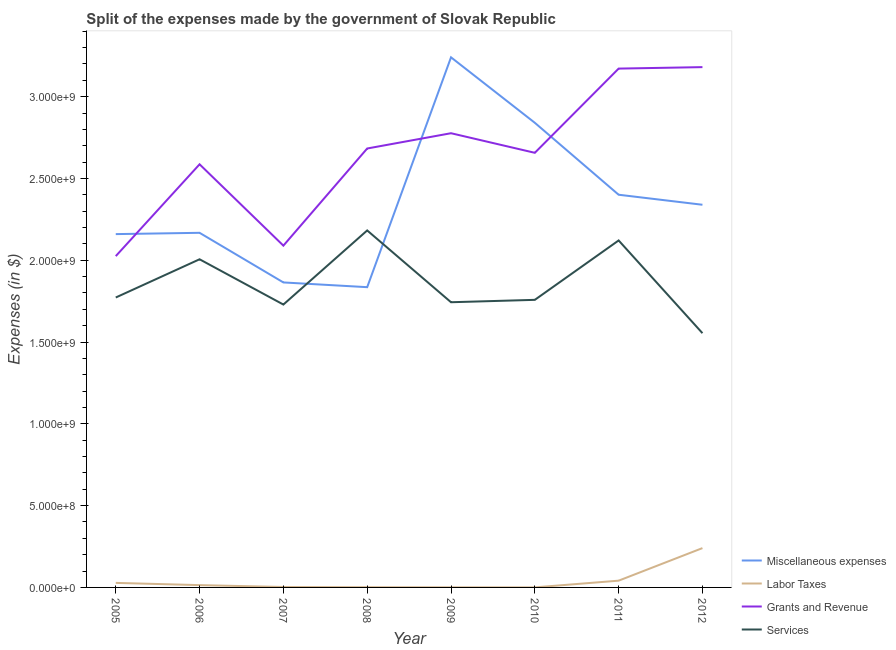What is the amount spent on grants and revenue in 2009?
Provide a short and direct response. 2.78e+09. Across all years, what is the maximum amount spent on grants and revenue?
Provide a succinct answer. 3.18e+09. Across all years, what is the minimum amount spent on miscellaneous expenses?
Provide a short and direct response. 1.84e+09. In which year was the amount spent on services maximum?
Your answer should be compact. 2008. What is the total amount spent on services in the graph?
Your answer should be compact. 1.49e+1. What is the difference between the amount spent on labor taxes in 2005 and that in 2012?
Ensure brevity in your answer.  -2.13e+08. What is the difference between the amount spent on grants and revenue in 2007 and the amount spent on services in 2006?
Offer a terse response. 8.34e+07. What is the average amount spent on miscellaneous expenses per year?
Offer a very short reply. 2.36e+09. In the year 2011, what is the difference between the amount spent on grants and revenue and amount spent on miscellaneous expenses?
Ensure brevity in your answer.  7.71e+08. In how many years, is the amount spent on miscellaneous expenses greater than 1100000000 $?
Provide a succinct answer. 8. What is the ratio of the amount spent on labor taxes in 2008 to that in 2009?
Offer a terse response. 1.92. Is the amount spent on services in 2005 less than that in 2006?
Provide a succinct answer. Yes. Is the difference between the amount spent on labor taxes in 2006 and 2010 greater than the difference between the amount spent on services in 2006 and 2010?
Provide a short and direct response. No. What is the difference between the highest and the second highest amount spent on labor taxes?
Offer a terse response. 1.99e+08. What is the difference between the highest and the lowest amount spent on services?
Provide a short and direct response. 6.28e+08. Is the sum of the amount spent on services in 2009 and 2012 greater than the maximum amount spent on grants and revenue across all years?
Provide a succinct answer. Yes. Is it the case that in every year, the sum of the amount spent on grants and revenue and amount spent on miscellaneous expenses is greater than the sum of amount spent on labor taxes and amount spent on services?
Offer a terse response. Yes. Is it the case that in every year, the sum of the amount spent on miscellaneous expenses and amount spent on labor taxes is greater than the amount spent on grants and revenue?
Your answer should be very brief. No. How many lines are there?
Keep it short and to the point. 4. Does the graph contain any zero values?
Offer a terse response. No. Where does the legend appear in the graph?
Your response must be concise. Bottom right. What is the title of the graph?
Make the answer very short. Split of the expenses made by the government of Slovak Republic. What is the label or title of the Y-axis?
Provide a succinct answer. Expenses (in $). What is the Expenses (in $) of Miscellaneous expenses in 2005?
Provide a succinct answer. 2.16e+09. What is the Expenses (in $) in Labor Taxes in 2005?
Your answer should be very brief. 2.77e+07. What is the Expenses (in $) in Grants and Revenue in 2005?
Offer a very short reply. 2.03e+09. What is the Expenses (in $) in Services in 2005?
Your response must be concise. 1.77e+09. What is the Expenses (in $) in Miscellaneous expenses in 2006?
Ensure brevity in your answer.  2.17e+09. What is the Expenses (in $) in Labor Taxes in 2006?
Give a very brief answer. 1.41e+07. What is the Expenses (in $) of Grants and Revenue in 2006?
Provide a succinct answer. 2.59e+09. What is the Expenses (in $) in Services in 2006?
Provide a succinct answer. 2.01e+09. What is the Expenses (in $) in Miscellaneous expenses in 2007?
Your response must be concise. 1.86e+09. What is the Expenses (in $) of Labor Taxes in 2007?
Give a very brief answer. 2.58e+06. What is the Expenses (in $) in Grants and Revenue in 2007?
Provide a short and direct response. 2.09e+09. What is the Expenses (in $) of Services in 2007?
Your answer should be compact. 1.73e+09. What is the Expenses (in $) of Miscellaneous expenses in 2008?
Offer a terse response. 1.84e+09. What is the Expenses (in $) in Labor Taxes in 2008?
Offer a very short reply. 1.39e+06. What is the Expenses (in $) of Grants and Revenue in 2008?
Keep it short and to the point. 2.68e+09. What is the Expenses (in $) of Services in 2008?
Your answer should be very brief. 2.18e+09. What is the Expenses (in $) in Miscellaneous expenses in 2009?
Offer a very short reply. 3.24e+09. What is the Expenses (in $) in Labor Taxes in 2009?
Your answer should be compact. 7.25e+05. What is the Expenses (in $) in Grants and Revenue in 2009?
Keep it short and to the point. 2.78e+09. What is the Expenses (in $) of Services in 2009?
Your answer should be very brief. 1.74e+09. What is the Expenses (in $) of Miscellaneous expenses in 2010?
Keep it short and to the point. 2.84e+09. What is the Expenses (in $) in Labor Taxes in 2010?
Your answer should be compact. 3.61e+05. What is the Expenses (in $) in Grants and Revenue in 2010?
Offer a terse response. 2.66e+09. What is the Expenses (in $) in Services in 2010?
Your answer should be very brief. 1.76e+09. What is the Expenses (in $) in Miscellaneous expenses in 2011?
Provide a short and direct response. 2.40e+09. What is the Expenses (in $) of Labor Taxes in 2011?
Make the answer very short. 4.13e+07. What is the Expenses (in $) of Grants and Revenue in 2011?
Offer a very short reply. 3.17e+09. What is the Expenses (in $) in Services in 2011?
Your answer should be compact. 2.12e+09. What is the Expenses (in $) of Miscellaneous expenses in 2012?
Ensure brevity in your answer.  2.34e+09. What is the Expenses (in $) of Labor Taxes in 2012?
Offer a terse response. 2.40e+08. What is the Expenses (in $) of Grants and Revenue in 2012?
Your answer should be compact. 3.18e+09. What is the Expenses (in $) of Services in 2012?
Make the answer very short. 1.55e+09. Across all years, what is the maximum Expenses (in $) of Miscellaneous expenses?
Give a very brief answer. 3.24e+09. Across all years, what is the maximum Expenses (in $) of Labor Taxes?
Offer a very short reply. 2.40e+08. Across all years, what is the maximum Expenses (in $) of Grants and Revenue?
Provide a short and direct response. 3.18e+09. Across all years, what is the maximum Expenses (in $) in Services?
Your response must be concise. 2.18e+09. Across all years, what is the minimum Expenses (in $) in Miscellaneous expenses?
Offer a terse response. 1.84e+09. Across all years, what is the minimum Expenses (in $) of Labor Taxes?
Provide a succinct answer. 3.61e+05. Across all years, what is the minimum Expenses (in $) in Grants and Revenue?
Make the answer very short. 2.03e+09. Across all years, what is the minimum Expenses (in $) in Services?
Provide a short and direct response. 1.55e+09. What is the total Expenses (in $) of Miscellaneous expenses in the graph?
Provide a succinct answer. 1.88e+1. What is the total Expenses (in $) of Labor Taxes in the graph?
Make the answer very short. 3.29e+08. What is the total Expenses (in $) of Grants and Revenue in the graph?
Offer a very short reply. 2.12e+1. What is the total Expenses (in $) in Services in the graph?
Keep it short and to the point. 1.49e+1. What is the difference between the Expenses (in $) of Miscellaneous expenses in 2005 and that in 2006?
Provide a succinct answer. -7.93e+06. What is the difference between the Expenses (in $) in Labor Taxes in 2005 and that in 2006?
Provide a short and direct response. 1.36e+07. What is the difference between the Expenses (in $) of Grants and Revenue in 2005 and that in 2006?
Offer a very short reply. -5.61e+08. What is the difference between the Expenses (in $) in Services in 2005 and that in 2006?
Make the answer very short. -2.34e+08. What is the difference between the Expenses (in $) in Miscellaneous expenses in 2005 and that in 2007?
Provide a succinct answer. 2.95e+08. What is the difference between the Expenses (in $) in Labor Taxes in 2005 and that in 2007?
Ensure brevity in your answer.  2.51e+07. What is the difference between the Expenses (in $) of Grants and Revenue in 2005 and that in 2007?
Make the answer very short. -6.41e+07. What is the difference between the Expenses (in $) of Services in 2005 and that in 2007?
Your response must be concise. 4.31e+07. What is the difference between the Expenses (in $) of Miscellaneous expenses in 2005 and that in 2008?
Provide a short and direct response. 3.24e+08. What is the difference between the Expenses (in $) in Labor Taxes in 2005 and that in 2008?
Ensure brevity in your answer.  2.63e+07. What is the difference between the Expenses (in $) of Grants and Revenue in 2005 and that in 2008?
Keep it short and to the point. -6.58e+08. What is the difference between the Expenses (in $) of Services in 2005 and that in 2008?
Provide a short and direct response. -4.10e+08. What is the difference between the Expenses (in $) of Miscellaneous expenses in 2005 and that in 2009?
Offer a terse response. -1.08e+09. What is the difference between the Expenses (in $) of Labor Taxes in 2005 and that in 2009?
Offer a terse response. 2.70e+07. What is the difference between the Expenses (in $) in Grants and Revenue in 2005 and that in 2009?
Make the answer very short. -7.51e+08. What is the difference between the Expenses (in $) in Services in 2005 and that in 2009?
Your answer should be very brief. 2.89e+07. What is the difference between the Expenses (in $) in Miscellaneous expenses in 2005 and that in 2010?
Make the answer very short. -6.81e+08. What is the difference between the Expenses (in $) in Labor Taxes in 2005 and that in 2010?
Provide a succinct answer. 2.73e+07. What is the difference between the Expenses (in $) of Grants and Revenue in 2005 and that in 2010?
Give a very brief answer. -6.32e+08. What is the difference between the Expenses (in $) of Services in 2005 and that in 2010?
Give a very brief answer. 1.44e+07. What is the difference between the Expenses (in $) of Miscellaneous expenses in 2005 and that in 2011?
Your response must be concise. -2.41e+08. What is the difference between the Expenses (in $) in Labor Taxes in 2005 and that in 2011?
Your response must be concise. -1.36e+07. What is the difference between the Expenses (in $) in Grants and Revenue in 2005 and that in 2011?
Offer a terse response. -1.15e+09. What is the difference between the Expenses (in $) in Services in 2005 and that in 2011?
Offer a terse response. -3.49e+08. What is the difference between the Expenses (in $) in Miscellaneous expenses in 2005 and that in 2012?
Offer a terse response. -1.79e+08. What is the difference between the Expenses (in $) of Labor Taxes in 2005 and that in 2012?
Your answer should be compact. -2.13e+08. What is the difference between the Expenses (in $) of Grants and Revenue in 2005 and that in 2012?
Your answer should be compact. -1.16e+09. What is the difference between the Expenses (in $) of Services in 2005 and that in 2012?
Give a very brief answer. 2.18e+08. What is the difference between the Expenses (in $) of Miscellaneous expenses in 2006 and that in 2007?
Your answer should be very brief. 3.03e+08. What is the difference between the Expenses (in $) in Labor Taxes in 2006 and that in 2007?
Offer a very short reply. 1.15e+07. What is the difference between the Expenses (in $) in Grants and Revenue in 2006 and that in 2007?
Offer a terse response. 4.97e+08. What is the difference between the Expenses (in $) in Services in 2006 and that in 2007?
Make the answer very short. 2.77e+08. What is the difference between the Expenses (in $) of Miscellaneous expenses in 2006 and that in 2008?
Keep it short and to the point. 3.32e+08. What is the difference between the Expenses (in $) in Labor Taxes in 2006 and that in 2008?
Give a very brief answer. 1.27e+07. What is the difference between the Expenses (in $) in Grants and Revenue in 2006 and that in 2008?
Keep it short and to the point. -9.66e+07. What is the difference between the Expenses (in $) in Services in 2006 and that in 2008?
Provide a short and direct response. -1.76e+08. What is the difference between the Expenses (in $) in Miscellaneous expenses in 2006 and that in 2009?
Your answer should be very brief. -1.07e+09. What is the difference between the Expenses (in $) in Labor Taxes in 2006 and that in 2009?
Keep it short and to the point. 1.34e+07. What is the difference between the Expenses (in $) of Grants and Revenue in 2006 and that in 2009?
Ensure brevity in your answer.  -1.90e+08. What is the difference between the Expenses (in $) in Services in 2006 and that in 2009?
Offer a terse response. 2.63e+08. What is the difference between the Expenses (in $) in Miscellaneous expenses in 2006 and that in 2010?
Your response must be concise. -6.73e+08. What is the difference between the Expenses (in $) of Labor Taxes in 2006 and that in 2010?
Make the answer very short. 1.37e+07. What is the difference between the Expenses (in $) in Grants and Revenue in 2006 and that in 2010?
Give a very brief answer. -7.03e+07. What is the difference between the Expenses (in $) in Services in 2006 and that in 2010?
Your response must be concise. 2.48e+08. What is the difference between the Expenses (in $) in Miscellaneous expenses in 2006 and that in 2011?
Your answer should be compact. -2.33e+08. What is the difference between the Expenses (in $) in Labor Taxes in 2006 and that in 2011?
Ensure brevity in your answer.  -2.72e+07. What is the difference between the Expenses (in $) in Grants and Revenue in 2006 and that in 2011?
Give a very brief answer. -5.85e+08. What is the difference between the Expenses (in $) in Services in 2006 and that in 2011?
Your answer should be compact. -1.15e+08. What is the difference between the Expenses (in $) of Miscellaneous expenses in 2006 and that in 2012?
Ensure brevity in your answer.  -1.72e+08. What is the difference between the Expenses (in $) in Labor Taxes in 2006 and that in 2012?
Your answer should be very brief. -2.26e+08. What is the difference between the Expenses (in $) of Grants and Revenue in 2006 and that in 2012?
Keep it short and to the point. -5.94e+08. What is the difference between the Expenses (in $) of Services in 2006 and that in 2012?
Give a very brief answer. 4.52e+08. What is the difference between the Expenses (in $) in Miscellaneous expenses in 2007 and that in 2008?
Ensure brevity in your answer.  2.90e+07. What is the difference between the Expenses (in $) in Labor Taxes in 2007 and that in 2008?
Make the answer very short. 1.19e+06. What is the difference between the Expenses (in $) in Grants and Revenue in 2007 and that in 2008?
Give a very brief answer. -5.94e+08. What is the difference between the Expenses (in $) of Services in 2007 and that in 2008?
Make the answer very short. -4.53e+08. What is the difference between the Expenses (in $) in Miscellaneous expenses in 2007 and that in 2009?
Your response must be concise. -1.38e+09. What is the difference between the Expenses (in $) of Labor Taxes in 2007 and that in 2009?
Your response must be concise. 1.86e+06. What is the difference between the Expenses (in $) in Grants and Revenue in 2007 and that in 2009?
Ensure brevity in your answer.  -6.87e+08. What is the difference between the Expenses (in $) of Services in 2007 and that in 2009?
Make the answer very short. -1.42e+07. What is the difference between the Expenses (in $) in Miscellaneous expenses in 2007 and that in 2010?
Give a very brief answer. -9.76e+08. What is the difference between the Expenses (in $) of Labor Taxes in 2007 and that in 2010?
Give a very brief answer. 2.22e+06. What is the difference between the Expenses (in $) of Grants and Revenue in 2007 and that in 2010?
Keep it short and to the point. -5.68e+08. What is the difference between the Expenses (in $) in Services in 2007 and that in 2010?
Make the answer very short. -2.88e+07. What is the difference between the Expenses (in $) of Miscellaneous expenses in 2007 and that in 2011?
Offer a very short reply. -5.36e+08. What is the difference between the Expenses (in $) of Labor Taxes in 2007 and that in 2011?
Keep it short and to the point. -3.87e+07. What is the difference between the Expenses (in $) in Grants and Revenue in 2007 and that in 2011?
Offer a very short reply. -1.08e+09. What is the difference between the Expenses (in $) in Services in 2007 and that in 2011?
Provide a short and direct response. -3.92e+08. What is the difference between the Expenses (in $) of Miscellaneous expenses in 2007 and that in 2012?
Ensure brevity in your answer.  -4.75e+08. What is the difference between the Expenses (in $) in Labor Taxes in 2007 and that in 2012?
Your answer should be compact. -2.38e+08. What is the difference between the Expenses (in $) of Grants and Revenue in 2007 and that in 2012?
Provide a succinct answer. -1.09e+09. What is the difference between the Expenses (in $) in Services in 2007 and that in 2012?
Keep it short and to the point. 1.75e+08. What is the difference between the Expenses (in $) in Miscellaneous expenses in 2008 and that in 2009?
Your answer should be very brief. -1.41e+09. What is the difference between the Expenses (in $) of Labor Taxes in 2008 and that in 2009?
Give a very brief answer. 6.67e+05. What is the difference between the Expenses (in $) in Grants and Revenue in 2008 and that in 2009?
Offer a terse response. -9.34e+07. What is the difference between the Expenses (in $) in Services in 2008 and that in 2009?
Your response must be concise. 4.39e+08. What is the difference between the Expenses (in $) in Miscellaneous expenses in 2008 and that in 2010?
Provide a short and direct response. -1.00e+09. What is the difference between the Expenses (in $) in Labor Taxes in 2008 and that in 2010?
Provide a succinct answer. 1.03e+06. What is the difference between the Expenses (in $) in Grants and Revenue in 2008 and that in 2010?
Keep it short and to the point. 2.63e+07. What is the difference between the Expenses (in $) of Services in 2008 and that in 2010?
Your answer should be very brief. 4.24e+08. What is the difference between the Expenses (in $) of Miscellaneous expenses in 2008 and that in 2011?
Your answer should be very brief. -5.65e+08. What is the difference between the Expenses (in $) in Labor Taxes in 2008 and that in 2011?
Ensure brevity in your answer.  -3.99e+07. What is the difference between the Expenses (in $) of Grants and Revenue in 2008 and that in 2011?
Keep it short and to the point. -4.88e+08. What is the difference between the Expenses (in $) in Services in 2008 and that in 2011?
Keep it short and to the point. 6.11e+07. What is the difference between the Expenses (in $) in Miscellaneous expenses in 2008 and that in 2012?
Offer a very short reply. -5.04e+08. What is the difference between the Expenses (in $) of Labor Taxes in 2008 and that in 2012?
Your response must be concise. -2.39e+08. What is the difference between the Expenses (in $) of Grants and Revenue in 2008 and that in 2012?
Provide a short and direct response. -4.97e+08. What is the difference between the Expenses (in $) in Services in 2008 and that in 2012?
Your answer should be compact. 6.28e+08. What is the difference between the Expenses (in $) of Miscellaneous expenses in 2009 and that in 2010?
Offer a very short reply. 4.00e+08. What is the difference between the Expenses (in $) in Labor Taxes in 2009 and that in 2010?
Offer a very short reply. 3.64e+05. What is the difference between the Expenses (in $) of Grants and Revenue in 2009 and that in 2010?
Make the answer very short. 1.20e+08. What is the difference between the Expenses (in $) of Services in 2009 and that in 2010?
Give a very brief answer. -1.45e+07. What is the difference between the Expenses (in $) of Miscellaneous expenses in 2009 and that in 2011?
Your response must be concise. 8.40e+08. What is the difference between the Expenses (in $) in Labor Taxes in 2009 and that in 2011?
Offer a terse response. -4.06e+07. What is the difference between the Expenses (in $) in Grants and Revenue in 2009 and that in 2011?
Give a very brief answer. -3.95e+08. What is the difference between the Expenses (in $) of Services in 2009 and that in 2011?
Ensure brevity in your answer.  -3.78e+08. What is the difference between the Expenses (in $) of Miscellaneous expenses in 2009 and that in 2012?
Ensure brevity in your answer.  9.01e+08. What is the difference between the Expenses (in $) in Labor Taxes in 2009 and that in 2012?
Your response must be concise. -2.40e+08. What is the difference between the Expenses (in $) of Grants and Revenue in 2009 and that in 2012?
Your answer should be compact. -4.04e+08. What is the difference between the Expenses (in $) of Services in 2009 and that in 2012?
Your answer should be very brief. 1.89e+08. What is the difference between the Expenses (in $) of Miscellaneous expenses in 2010 and that in 2011?
Your response must be concise. 4.40e+08. What is the difference between the Expenses (in $) in Labor Taxes in 2010 and that in 2011?
Provide a succinct answer. -4.10e+07. What is the difference between the Expenses (in $) of Grants and Revenue in 2010 and that in 2011?
Offer a terse response. -5.15e+08. What is the difference between the Expenses (in $) of Services in 2010 and that in 2011?
Offer a terse response. -3.63e+08. What is the difference between the Expenses (in $) of Miscellaneous expenses in 2010 and that in 2012?
Make the answer very short. 5.01e+08. What is the difference between the Expenses (in $) in Labor Taxes in 2010 and that in 2012?
Your answer should be very brief. -2.40e+08. What is the difference between the Expenses (in $) of Grants and Revenue in 2010 and that in 2012?
Keep it short and to the point. -5.24e+08. What is the difference between the Expenses (in $) of Services in 2010 and that in 2012?
Your answer should be compact. 2.04e+08. What is the difference between the Expenses (in $) of Miscellaneous expenses in 2011 and that in 2012?
Offer a very short reply. 6.13e+07. What is the difference between the Expenses (in $) of Labor Taxes in 2011 and that in 2012?
Provide a short and direct response. -1.99e+08. What is the difference between the Expenses (in $) of Grants and Revenue in 2011 and that in 2012?
Your answer should be compact. -8.98e+06. What is the difference between the Expenses (in $) of Services in 2011 and that in 2012?
Give a very brief answer. 5.67e+08. What is the difference between the Expenses (in $) of Miscellaneous expenses in 2005 and the Expenses (in $) of Labor Taxes in 2006?
Provide a succinct answer. 2.15e+09. What is the difference between the Expenses (in $) in Miscellaneous expenses in 2005 and the Expenses (in $) in Grants and Revenue in 2006?
Your answer should be compact. -4.27e+08. What is the difference between the Expenses (in $) in Miscellaneous expenses in 2005 and the Expenses (in $) in Services in 2006?
Provide a short and direct response. 1.54e+08. What is the difference between the Expenses (in $) of Labor Taxes in 2005 and the Expenses (in $) of Grants and Revenue in 2006?
Offer a terse response. -2.56e+09. What is the difference between the Expenses (in $) of Labor Taxes in 2005 and the Expenses (in $) of Services in 2006?
Offer a very short reply. -1.98e+09. What is the difference between the Expenses (in $) in Grants and Revenue in 2005 and the Expenses (in $) in Services in 2006?
Ensure brevity in your answer.  1.93e+07. What is the difference between the Expenses (in $) of Miscellaneous expenses in 2005 and the Expenses (in $) of Labor Taxes in 2007?
Provide a short and direct response. 2.16e+09. What is the difference between the Expenses (in $) of Miscellaneous expenses in 2005 and the Expenses (in $) of Grants and Revenue in 2007?
Your answer should be compact. 7.04e+07. What is the difference between the Expenses (in $) in Miscellaneous expenses in 2005 and the Expenses (in $) in Services in 2007?
Offer a very short reply. 4.31e+08. What is the difference between the Expenses (in $) in Labor Taxes in 2005 and the Expenses (in $) in Grants and Revenue in 2007?
Your response must be concise. -2.06e+09. What is the difference between the Expenses (in $) of Labor Taxes in 2005 and the Expenses (in $) of Services in 2007?
Keep it short and to the point. -1.70e+09. What is the difference between the Expenses (in $) of Grants and Revenue in 2005 and the Expenses (in $) of Services in 2007?
Make the answer very short. 2.96e+08. What is the difference between the Expenses (in $) in Miscellaneous expenses in 2005 and the Expenses (in $) in Labor Taxes in 2008?
Keep it short and to the point. 2.16e+09. What is the difference between the Expenses (in $) in Miscellaneous expenses in 2005 and the Expenses (in $) in Grants and Revenue in 2008?
Offer a terse response. -5.23e+08. What is the difference between the Expenses (in $) in Miscellaneous expenses in 2005 and the Expenses (in $) in Services in 2008?
Your answer should be compact. -2.25e+07. What is the difference between the Expenses (in $) in Labor Taxes in 2005 and the Expenses (in $) in Grants and Revenue in 2008?
Offer a terse response. -2.66e+09. What is the difference between the Expenses (in $) of Labor Taxes in 2005 and the Expenses (in $) of Services in 2008?
Offer a terse response. -2.15e+09. What is the difference between the Expenses (in $) in Grants and Revenue in 2005 and the Expenses (in $) in Services in 2008?
Your answer should be compact. -1.57e+08. What is the difference between the Expenses (in $) in Miscellaneous expenses in 2005 and the Expenses (in $) in Labor Taxes in 2009?
Make the answer very short. 2.16e+09. What is the difference between the Expenses (in $) in Miscellaneous expenses in 2005 and the Expenses (in $) in Grants and Revenue in 2009?
Your answer should be compact. -6.17e+08. What is the difference between the Expenses (in $) in Miscellaneous expenses in 2005 and the Expenses (in $) in Services in 2009?
Ensure brevity in your answer.  4.16e+08. What is the difference between the Expenses (in $) of Labor Taxes in 2005 and the Expenses (in $) of Grants and Revenue in 2009?
Ensure brevity in your answer.  -2.75e+09. What is the difference between the Expenses (in $) of Labor Taxes in 2005 and the Expenses (in $) of Services in 2009?
Ensure brevity in your answer.  -1.72e+09. What is the difference between the Expenses (in $) in Grants and Revenue in 2005 and the Expenses (in $) in Services in 2009?
Your answer should be very brief. 2.82e+08. What is the difference between the Expenses (in $) in Miscellaneous expenses in 2005 and the Expenses (in $) in Labor Taxes in 2010?
Your answer should be compact. 2.16e+09. What is the difference between the Expenses (in $) in Miscellaneous expenses in 2005 and the Expenses (in $) in Grants and Revenue in 2010?
Offer a terse response. -4.97e+08. What is the difference between the Expenses (in $) of Miscellaneous expenses in 2005 and the Expenses (in $) of Services in 2010?
Offer a very short reply. 4.02e+08. What is the difference between the Expenses (in $) of Labor Taxes in 2005 and the Expenses (in $) of Grants and Revenue in 2010?
Keep it short and to the point. -2.63e+09. What is the difference between the Expenses (in $) in Labor Taxes in 2005 and the Expenses (in $) in Services in 2010?
Provide a short and direct response. -1.73e+09. What is the difference between the Expenses (in $) of Grants and Revenue in 2005 and the Expenses (in $) of Services in 2010?
Offer a very short reply. 2.67e+08. What is the difference between the Expenses (in $) in Miscellaneous expenses in 2005 and the Expenses (in $) in Labor Taxes in 2011?
Give a very brief answer. 2.12e+09. What is the difference between the Expenses (in $) in Miscellaneous expenses in 2005 and the Expenses (in $) in Grants and Revenue in 2011?
Your answer should be very brief. -1.01e+09. What is the difference between the Expenses (in $) in Miscellaneous expenses in 2005 and the Expenses (in $) in Services in 2011?
Your response must be concise. 3.87e+07. What is the difference between the Expenses (in $) of Labor Taxes in 2005 and the Expenses (in $) of Grants and Revenue in 2011?
Keep it short and to the point. -3.14e+09. What is the difference between the Expenses (in $) of Labor Taxes in 2005 and the Expenses (in $) of Services in 2011?
Provide a succinct answer. -2.09e+09. What is the difference between the Expenses (in $) of Grants and Revenue in 2005 and the Expenses (in $) of Services in 2011?
Offer a very short reply. -9.59e+07. What is the difference between the Expenses (in $) of Miscellaneous expenses in 2005 and the Expenses (in $) of Labor Taxes in 2012?
Provide a short and direct response. 1.92e+09. What is the difference between the Expenses (in $) in Miscellaneous expenses in 2005 and the Expenses (in $) in Grants and Revenue in 2012?
Provide a succinct answer. -1.02e+09. What is the difference between the Expenses (in $) in Miscellaneous expenses in 2005 and the Expenses (in $) in Services in 2012?
Your answer should be very brief. 6.06e+08. What is the difference between the Expenses (in $) in Labor Taxes in 2005 and the Expenses (in $) in Grants and Revenue in 2012?
Your answer should be very brief. -3.15e+09. What is the difference between the Expenses (in $) in Labor Taxes in 2005 and the Expenses (in $) in Services in 2012?
Your answer should be very brief. -1.53e+09. What is the difference between the Expenses (in $) of Grants and Revenue in 2005 and the Expenses (in $) of Services in 2012?
Your answer should be very brief. 4.71e+08. What is the difference between the Expenses (in $) in Miscellaneous expenses in 2006 and the Expenses (in $) in Labor Taxes in 2007?
Keep it short and to the point. 2.17e+09. What is the difference between the Expenses (in $) in Miscellaneous expenses in 2006 and the Expenses (in $) in Grants and Revenue in 2007?
Give a very brief answer. 7.84e+07. What is the difference between the Expenses (in $) in Miscellaneous expenses in 2006 and the Expenses (in $) in Services in 2007?
Your answer should be very brief. 4.39e+08. What is the difference between the Expenses (in $) in Labor Taxes in 2006 and the Expenses (in $) in Grants and Revenue in 2007?
Your answer should be very brief. -2.08e+09. What is the difference between the Expenses (in $) of Labor Taxes in 2006 and the Expenses (in $) of Services in 2007?
Your answer should be compact. -1.72e+09. What is the difference between the Expenses (in $) in Grants and Revenue in 2006 and the Expenses (in $) in Services in 2007?
Give a very brief answer. 8.57e+08. What is the difference between the Expenses (in $) of Miscellaneous expenses in 2006 and the Expenses (in $) of Labor Taxes in 2008?
Ensure brevity in your answer.  2.17e+09. What is the difference between the Expenses (in $) of Miscellaneous expenses in 2006 and the Expenses (in $) of Grants and Revenue in 2008?
Ensure brevity in your answer.  -5.15e+08. What is the difference between the Expenses (in $) of Miscellaneous expenses in 2006 and the Expenses (in $) of Services in 2008?
Your response must be concise. -1.45e+07. What is the difference between the Expenses (in $) in Labor Taxes in 2006 and the Expenses (in $) in Grants and Revenue in 2008?
Provide a short and direct response. -2.67e+09. What is the difference between the Expenses (in $) of Labor Taxes in 2006 and the Expenses (in $) of Services in 2008?
Offer a terse response. -2.17e+09. What is the difference between the Expenses (in $) of Grants and Revenue in 2006 and the Expenses (in $) of Services in 2008?
Provide a succinct answer. 4.04e+08. What is the difference between the Expenses (in $) in Miscellaneous expenses in 2006 and the Expenses (in $) in Labor Taxes in 2009?
Your answer should be very brief. 2.17e+09. What is the difference between the Expenses (in $) of Miscellaneous expenses in 2006 and the Expenses (in $) of Grants and Revenue in 2009?
Provide a succinct answer. -6.09e+08. What is the difference between the Expenses (in $) in Miscellaneous expenses in 2006 and the Expenses (in $) in Services in 2009?
Offer a terse response. 4.24e+08. What is the difference between the Expenses (in $) in Labor Taxes in 2006 and the Expenses (in $) in Grants and Revenue in 2009?
Ensure brevity in your answer.  -2.76e+09. What is the difference between the Expenses (in $) of Labor Taxes in 2006 and the Expenses (in $) of Services in 2009?
Your answer should be very brief. -1.73e+09. What is the difference between the Expenses (in $) in Grants and Revenue in 2006 and the Expenses (in $) in Services in 2009?
Your answer should be very brief. 8.43e+08. What is the difference between the Expenses (in $) in Miscellaneous expenses in 2006 and the Expenses (in $) in Labor Taxes in 2010?
Offer a terse response. 2.17e+09. What is the difference between the Expenses (in $) in Miscellaneous expenses in 2006 and the Expenses (in $) in Grants and Revenue in 2010?
Your answer should be very brief. -4.89e+08. What is the difference between the Expenses (in $) in Miscellaneous expenses in 2006 and the Expenses (in $) in Services in 2010?
Your answer should be compact. 4.10e+08. What is the difference between the Expenses (in $) in Labor Taxes in 2006 and the Expenses (in $) in Grants and Revenue in 2010?
Give a very brief answer. -2.64e+09. What is the difference between the Expenses (in $) of Labor Taxes in 2006 and the Expenses (in $) of Services in 2010?
Keep it short and to the point. -1.74e+09. What is the difference between the Expenses (in $) in Grants and Revenue in 2006 and the Expenses (in $) in Services in 2010?
Offer a very short reply. 8.29e+08. What is the difference between the Expenses (in $) in Miscellaneous expenses in 2006 and the Expenses (in $) in Labor Taxes in 2011?
Ensure brevity in your answer.  2.13e+09. What is the difference between the Expenses (in $) in Miscellaneous expenses in 2006 and the Expenses (in $) in Grants and Revenue in 2011?
Give a very brief answer. -1.00e+09. What is the difference between the Expenses (in $) in Miscellaneous expenses in 2006 and the Expenses (in $) in Services in 2011?
Provide a succinct answer. 4.66e+07. What is the difference between the Expenses (in $) of Labor Taxes in 2006 and the Expenses (in $) of Grants and Revenue in 2011?
Give a very brief answer. -3.16e+09. What is the difference between the Expenses (in $) of Labor Taxes in 2006 and the Expenses (in $) of Services in 2011?
Ensure brevity in your answer.  -2.11e+09. What is the difference between the Expenses (in $) in Grants and Revenue in 2006 and the Expenses (in $) in Services in 2011?
Offer a very short reply. 4.65e+08. What is the difference between the Expenses (in $) of Miscellaneous expenses in 2006 and the Expenses (in $) of Labor Taxes in 2012?
Provide a short and direct response. 1.93e+09. What is the difference between the Expenses (in $) of Miscellaneous expenses in 2006 and the Expenses (in $) of Grants and Revenue in 2012?
Make the answer very short. -1.01e+09. What is the difference between the Expenses (in $) in Miscellaneous expenses in 2006 and the Expenses (in $) in Services in 2012?
Offer a terse response. 6.13e+08. What is the difference between the Expenses (in $) in Labor Taxes in 2006 and the Expenses (in $) in Grants and Revenue in 2012?
Offer a terse response. -3.17e+09. What is the difference between the Expenses (in $) of Labor Taxes in 2006 and the Expenses (in $) of Services in 2012?
Offer a terse response. -1.54e+09. What is the difference between the Expenses (in $) of Grants and Revenue in 2006 and the Expenses (in $) of Services in 2012?
Your answer should be very brief. 1.03e+09. What is the difference between the Expenses (in $) in Miscellaneous expenses in 2007 and the Expenses (in $) in Labor Taxes in 2008?
Your response must be concise. 1.86e+09. What is the difference between the Expenses (in $) of Miscellaneous expenses in 2007 and the Expenses (in $) of Grants and Revenue in 2008?
Your response must be concise. -8.19e+08. What is the difference between the Expenses (in $) of Miscellaneous expenses in 2007 and the Expenses (in $) of Services in 2008?
Your answer should be compact. -3.18e+08. What is the difference between the Expenses (in $) in Labor Taxes in 2007 and the Expenses (in $) in Grants and Revenue in 2008?
Your answer should be compact. -2.68e+09. What is the difference between the Expenses (in $) of Labor Taxes in 2007 and the Expenses (in $) of Services in 2008?
Ensure brevity in your answer.  -2.18e+09. What is the difference between the Expenses (in $) in Grants and Revenue in 2007 and the Expenses (in $) in Services in 2008?
Keep it short and to the point. -9.29e+07. What is the difference between the Expenses (in $) in Miscellaneous expenses in 2007 and the Expenses (in $) in Labor Taxes in 2009?
Offer a very short reply. 1.86e+09. What is the difference between the Expenses (in $) of Miscellaneous expenses in 2007 and the Expenses (in $) of Grants and Revenue in 2009?
Ensure brevity in your answer.  -9.12e+08. What is the difference between the Expenses (in $) of Miscellaneous expenses in 2007 and the Expenses (in $) of Services in 2009?
Offer a very short reply. 1.21e+08. What is the difference between the Expenses (in $) in Labor Taxes in 2007 and the Expenses (in $) in Grants and Revenue in 2009?
Provide a succinct answer. -2.77e+09. What is the difference between the Expenses (in $) of Labor Taxes in 2007 and the Expenses (in $) of Services in 2009?
Give a very brief answer. -1.74e+09. What is the difference between the Expenses (in $) in Grants and Revenue in 2007 and the Expenses (in $) in Services in 2009?
Your answer should be very brief. 3.46e+08. What is the difference between the Expenses (in $) in Miscellaneous expenses in 2007 and the Expenses (in $) in Labor Taxes in 2010?
Your answer should be very brief. 1.86e+09. What is the difference between the Expenses (in $) in Miscellaneous expenses in 2007 and the Expenses (in $) in Grants and Revenue in 2010?
Your response must be concise. -7.92e+08. What is the difference between the Expenses (in $) of Miscellaneous expenses in 2007 and the Expenses (in $) of Services in 2010?
Provide a short and direct response. 1.06e+08. What is the difference between the Expenses (in $) of Labor Taxes in 2007 and the Expenses (in $) of Grants and Revenue in 2010?
Give a very brief answer. -2.65e+09. What is the difference between the Expenses (in $) in Labor Taxes in 2007 and the Expenses (in $) in Services in 2010?
Ensure brevity in your answer.  -1.76e+09. What is the difference between the Expenses (in $) in Grants and Revenue in 2007 and the Expenses (in $) in Services in 2010?
Your answer should be very brief. 3.31e+08. What is the difference between the Expenses (in $) in Miscellaneous expenses in 2007 and the Expenses (in $) in Labor Taxes in 2011?
Offer a terse response. 1.82e+09. What is the difference between the Expenses (in $) in Miscellaneous expenses in 2007 and the Expenses (in $) in Grants and Revenue in 2011?
Offer a very short reply. -1.31e+09. What is the difference between the Expenses (in $) in Miscellaneous expenses in 2007 and the Expenses (in $) in Services in 2011?
Provide a short and direct response. -2.57e+08. What is the difference between the Expenses (in $) of Labor Taxes in 2007 and the Expenses (in $) of Grants and Revenue in 2011?
Give a very brief answer. -3.17e+09. What is the difference between the Expenses (in $) of Labor Taxes in 2007 and the Expenses (in $) of Services in 2011?
Offer a very short reply. -2.12e+09. What is the difference between the Expenses (in $) of Grants and Revenue in 2007 and the Expenses (in $) of Services in 2011?
Give a very brief answer. -3.18e+07. What is the difference between the Expenses (in $) of Miscellaneous expenses in 2007 and the Expenses (in $) of Labor Taxes in 2012?
Your answer should be compact. 1.62e+09. What is the difference between the Expenses (in $) in Miscellaneous expenses in 2007 and the Expenses (in $) in Grants and Revenue in 2012?
Your answer should be very brief. -1.32e+09. What is the difference between the Expenses (in $) of Miscellaneous expenses in 2007 and the Expenses (in $) of Services in 2012?
Your answer should be very brief. 3.10e+08. What is the difference between the Expenses (in $) in Labor Taxes in 2007 and the Expenses (in $) in Grants and Revenue in 2012?
Provide a succinct answer. -3.18e+09. What is the difference between the Expenses (in $) of Labor Taxes in 2007 and the Expenses (in $) of Services in 2012?
Make the answer very short. -1.55e+09. What is the difference between the Expenses (in $) of Grants and Revenue in 2007 and the Expenses (in $) of Services in 2012?
Your response must be concise. 5.35e+08. What is the difference between the Expenses (in $) in Miscellaneous expenses in 2008 and the Expenses (in $) in Labor Taxes in 2009?
Keep it short and to the point. 1.83e+09. What is the difference between the Expenses (in $) of Miscellaneous expenses in 2008 and the Expenses (in $) of Grants and Revenue in 2009?
Provide a succinct answer. -9.41e+08. What is the difference between the Expenses (in $) of Miscellaneous expenses in 2008 and the Expenses (in $) of Services in 2009?
Your answer should be compact. 9.20e+07. What is the difference between the Expenses (in $) in Labor Taxes in 2008 and the Expenses (in $) in Grants and Revenue in 2009?
Keep it short and to the point. -2.78e+09. What is the difference between the Expenses (in $) in Labor Taxes in 2008 and the Expenses (in $) in Services in 2009?
Make the answer very short. -1.74e+09. What is the difference between the Expenses (in $) of Grants and Revenue in 2008 and the Expenses (in $) of Services in 2009?
Your answer should be compact. 9.40e+08. What is the difference between the Expenses (in $) of Miscellaneous expenses in 2008 and the Expenses (in $) of Labor Taxes in 2010?
Offer a very short reply. 1.84e+09. What is the difference between the Expenses (in $) of Miscellaneous expenses in 2008 and the Expenses (in $) of Grants and Revenue in 2010?
Keep it short and to the point. -8.21e+08. What is the difference between the Expenses (in $) of Miscellaneous expenses in 2008 and the Expenses (in $) of Services in 2010?
Offer a terse response. 7.75e+07. What is the difference between the Expenses (in $) of Labor Taxes in 2008 and the Expenses (in $) of Grants and Revenue in 2010?
Make the answer very short. -2.66e+09. What is the difference between the Expenses (in $) in Labor Taxes in 2008 and the Expenses (in $) in Services in 2010?
Offer a very short reply. -1.76e+09. What is the difference between the Expenses (in $) in Grants and Revenue in 2008 and the Expenses (in $) in Services in 2010?
Make the answer very short. 9.25e+08. What is the difference between the Expenses (in $) of Miscellaneous expenses in 2008 and the Expenses (in $) of Labor Taxes in 2011?
Your response must be concise. 1.79e+09. What is the difference between the Expenses (in $) of Miscellaneous expenses in 2008 and the Expenses (in $) of Grants and Revenue in 2011?
Offer a very short reply. -1.34e+09. What is the difference between the Expenses (in $) in Miscellaneous expenses in 2008 and the Expenses (in $) in Services in 2011?
Offer a terse response. -2.86e+08. What is the difference between the Expenses (in $) in Labor Taxes in 2008 and the Expenses (in $) in Grants and Revenue in 2011?
Provide a succinct answer. -3.17e+09. What is the difference between the Expenses (in $) in Labor Taxes in 2008 and the Expenses (in $) in Services in 2011?
Make the answer very short. -2.12e+09. What is the difference between the Expenses (in $) of Grants and Revenue in 2008 and the Expenses (in $) of Services in 2011?
Your response must be concise. 5.62e+08. What is the difference between the Expenses (in $) of Miscellaneous expenses in 2008 and the Expenses (in $) of Labor Taxes in 2012?
Offer a terse response. 1.60e+09. What is the difference between the Expenses (in $) of Miscellaneous expenses in 2008 and the Expenses (in $) of Grants and Revenue in 2012?
Provide a succinct answer. -1.35e+09. What is the difference between the Expenses (in $) in Miscellaneous expenses in 2008 and the Expenses (in $) in Services in 2012?
Offer a very short reply. 2.81e+08. What is the difference between the Expenses (in $) in Labor Taxes in 2008 and the Expenses (in $) in Grants and Revenue in 2012?
Make the answer very short. -3.18e+09. What is the difference between the Expenses (in $) in Labor Taxes in 2008 and the Expenses (in $) in Services in 2012?
Offer a terse response. -1.55e+09. What is the difference between the Expenses (in $) in Grants and Revenue in 2008 and the Expenses (in $) in Services in 2012?
Your answer should be very brief. 1.13e+09. What is the difference between the Expenses (in $) in Miscellaneous expenses in 2009 and the Expenses (in $) in Labor Taxes in 2010?
Your answer should be compact. 3.24e+09. What is the difference between the Expenses (in $) of Miscellaneous expenses in 2009 and the Expenses (in $) of Grants and Revenue in 2010?
Keep it short and to the point. 5.84e+08. What is the difference between the Expenses (in $) of Miscellaneous expenses in 2009 and the Expenses (in $) of Services in 2010?
Your response must be concise. 1.48e+09. What is the difference between the Expenses (in $) in Labor Taxes in 2009 and the Expenses (in $) in Grants and Revenue in 2010?
Your answer should be very brief. -2.66e+09. What is the difference between the Expenses (in $) in Labor Taxes in 2009 and the Expenses (in $) in Services in 2010?
Give a very brief answer. -1.76e+09. What is the difference between the Expenses (in $) of Grants and Revenue in 2009 and the Expenses (in $) of Services in 2010?
Your response must be concise. 1.02e+09. What is the difference between the Expenses (in $) of Miscellaneous expenses in 2009 and the Expenses (in $) of Labor Taxes in 2011?
Ensure brevity in your answer.  3.20e+09. What is the difference between the Expenses (in $) in Miscellaneous expenses in 2009 and the Expenses (in $) in Grants and Revenue in 2011?
Make the answer very short. 6.89e+07. What is the difference between the Expenses (in $) of Miscellaneous expenses in 2009 and the Expenses (in $) of Services in 2011?
Offer a very short reply. 1.12e+09. What is the difference between the Expenses (in $) in Labor Taxes in 2009 and the Expenses (in $) in Grants and Revenue in 2011?
Ensure brevity in your answer.  -3.17e+09. What is the difference between the Expenses (in $) in Labor Taxes in 2009 and the Expenses (in $) in Services in 2011?
Your answer should be very brief. -2.12e+09. What is the difference between the Expenses (in $) in Grants and Revenue in 2009 and the Expenses (in $) in Services in 2011?
Give a very brief answer. 6.55e+08. What is the difference between the Expenses (in $) of Miscellaneous expenses in 2009 and the Expenses (in $) of Labor Taxes in 2012?
Offer a very short reply. 3.00e+09. What is the difference between the Expenses (in $) of Miscellaneous expenses in 2009 and the Expenses (in $) of Grants and Revenue in 2012?
Provide a succinct answer. 5.99e+07. What is the difference between the Expenses (in $) of Miscellaneous expenses in 2009 and the Expenses (in $) of Services in 2012?
Provide a succinct answer. 1.69e+09. What is the difference between the Expenses (in $) in Labor Taxes in 2009 and the Expenses (in $) in Grants and Revenue in 2012?
Give a very brief answer. -3.18e+09. What is the difference between the Expenses (in $) in Labor Taxes in 2009 and the Expenses (in $) in Services in 2012?
Offer a terse response. -1.55e+09. What is the difference between the Expenses (in $) in Grants and Revenue in 2009 and the Expenses (in $) in Services in 2012?
Your answer should be very brief. 1.22e+09. What is the difference between the Expenses (in $) of Miscellaneous expenses in 2010 and the Expenses (in $) of Labor Taxes in 2011?
Your answer should be compact. 2.80e+09. What is the difference between the Expenses (in $) of Miscellaneous expenses in 2010 and the Expenses (in $) of Grants and Revenue in 2011?
Provide a short and direct response. -3.31e+08. What is the difference between the Expenses (in $) in Miscellaneous expenses in 2010 and the Expenses (in $) in Services in 2011?
Your answer should be very brief. 7.19e+08. What is the difference between the Expenses (in $) in Labor Taxes in 2010 and the Expenses (in $) in Grants and Revenue in 2011?
Provide a short and direct response. -3.17e+09. What is the difference between the Expenses (in $) in Labor Taxes in 2010 and the Expenses (in $) in Services in 2011?
Ensure brevity in your answer.  -2.12e+09. What is the difference between the Expenses (in $) in Grants and Revenue in 2010 and the Expenses (in $) in Services in 2011?
Offer a terse response. 5.36e+08. What is the difference between the Expenses (in $) in Miscellaneous expenses in 2010 and the Expenses (in $) in Labor Taxes in 2012?
Your answer should be compact. 2.60e+09. What is the difference between the Expenses (in $) of Miscellaneous expenses in 2010 and the Expenses (in $) of Grants and Revenue in 2012?
Your answer should be very brief. -3.40e+08. What is the difference between the Expenses (in $) of Miscellaneous expenses in 2010 and the Expenses (in $) of Services in 2012?
Offer a very short reply. 1.29e+09. What is the difference between the Expenses (in $) in Labor Taxes in 2010 and the Expenses (in $) in Grants and Revenue in 2012?
Offer a very short reply. -3.18e+09. What is the difference between the Expenses (in $) in Labor Taxes in 2010 and the Expenses (in $) in Services in 2012?
Your response must be concise. -1.55e+09. What is the difference between the Expenses (in $) in Grants and Revenue in 2010 and the Expenses (in $) in Services in 2012?
Give a very brief answer. 1.10e+09. What is the difference between the Expenses (in $) in Miscellaneous expenses in 2011 and the Expenses (in $) in Labor Taxes in 2012?
Keep it short and to the point. 2.16e+09. What is the difference between the Expenses (in $) of Miscellaneous expenses in 2011 and the Expenses (in $) of Grants and Revenue in 2012?
Offer a terse response. -7.80e+08. What is the difference between the Expenses (in $) of Miscellaneous expenses in 2011 and the Expenses (in $) of Services in 2012?
Your answer should be compact. 8.46e+08. What is the difference between the Expenses (in $) of Labor Taxes in 2011 and the Expenses (in $) of Grants and Revenue in 2012?
Ensure brevity in your answer.  -3.14e+09. What is the difference between the Expenses (in $) of Labor Taxes in 2011 and the Expenses (in $) of Services in 2012?
Provide a short and direct response. -1.51e+09. What is the difference between the Expenses (in $) of Grants and Revenue in 2011 and the Expenses (in $) of Services in 2012?
Keep it short and to the point. 1.62e+09. What is the average Expenses (in $) of Miscellaneous expenses per year?
Offer a terse response. 2.36e+09. What is the average Expenses (in $) in Labor Taxes per year?
Your answer should be compact. 4.11e+07. What is the average Expenses (in $) of Grants and Revenue per year?
Ensure brevity in your answer.  2.65e+09. What is the average Expenses (in $) in Services per year?
Give a very brief answer. 1.86e+09. In the year 2005, what is the difference between the Expenses (in $) in Miscellaneous expenses and Expenses (in $) in Labor Taxes?
Your answer should be very brief. 2.13e+09. In the year 2005, what is the difference between the Expenses (in $) in Miscellaneous expenses and Expenses (in $) in Grants and Revenue?
Your answer should be very brief. 1.35e+08. In the year 2005, what is the difference between the Expenses (in $) of Miscellaneous expenses and Expenses (in $) of Services?
Provide a succinct answer. 3.87e+08. In the year 2005, what is the difference between the Expenses (in $) of Labor Taxes and Expenses (in $) of Grants and Revenue?
Your answer should be very brief. -2.00e+09. In the year 2005, what is the difference between the Expenses (in $) of Labor Taxes and Expenses (in $) of Services?
Offer a very short reply. -1.74e+09. In the year 2005, what is the difference between the Expenses (in $) of Grants and Revenue and Expenses (in $) of Services?
Offer a very short reply. 2.53e+08. In the year 2006, what is the difference between the Expenses (in $) of Miscellaneous expenses and Expenses (in $) of Labor Taxes?
Provide a succinct answer. 2.15e+09. In the year 2006, what is the difference between the Expenses (in $) of Miscellaneous expenses and Expenses (in $) of Grants and Revenue?
Provide a succinct answer. -4.19e+08. In the year 2006, what is the difference between the Expenses (in $) of Miscellaneous expenses and Expenses (in $) of Services?
Provide a succinct answer. 1.62e+08. In the year 2006, what is the difference between the Expenses (in $) of Labor Taxes and Expenses (in $) of Grants and Revenue?
Your answer should be compact. -2.57e+09. In the year 2006, what is the difference between the Expenses (in $) of Labor Taxes and Expenses (in $) of Services?
Provide a succinct answer. -1.99e+09. In the year 2006, what is the difference between the Expenses (in $) in Grants and Revenue and Expenses (in $) in Services?
Provide a short and direct response. 5.81e+08. In the year 2007, what is the difference between the Expenses (in $) of Miscellaneous expenses and Expenses (in $) of Labor Taxes?
Keep it short and to the point. 1.86e+09. In the year 2007, what is the difference between the Expenses (in $) of Miscellaneous expenses and Expenses (in $) of Grants and Revenue?
Offer a very short reply. -2.25e+08. In the year 2007, what is the difference between the Expenses (in $) of Miscellaneous expenses and Expenses (in $) of Services?
Offer a very short reply. 1.35e+08. In the year 2007, what is the difference between the Expenses (in $) of Labor Taxes and Expenses (in $) of Grants and Revenue?
Offer a very short reply. -2.09e+09. In the year 2007, what is the difference between the Expenses (in $) of Labor Taxes and Expenses (in $) of Services?
Give a very brief answer. -1.73e+09. In the year 2007, what is the difference between the Expenses (in $) of Grants and Revenue and Expenses (in $) of Services?
Give a very brief answer. 3.60e+08. In the year 2008, what is the difference between the Expenses (in $) in Miscellaneous expenses and Expenses (in $) in Labor Taxes?
Your answer should be very brief. 1.83e+09. In the year 2008, what is the difference between the Expenses (in $) in Miscellaneous expenses and Expenses (in $) in Grants and Revenue?
Ensure brevity in your answer.  -8.48e+08. In the year 2008, what is the difference between the Expenses (in $) of Miscellaneous expenses and Expenses (in $) of Services?
Your response must be concise. -3.47e+08. In the year 2008, what is the difference between the Expenses (in $) in Labor Taxes and Expenses (in $) in Grants and Revenue?
Make the answer very short. -2.68e+09. In the year 2008, what is the difference between the Expenses (in $) in Labor Taxes and Expenses (in $) in Services?
Offer a very short reply. -2.18e+09. In the year 2008, what is the difference between the Expenses (in $) of Grants and Revenue and Expenses (in $) of Services?
Keep it short and to the point. 5.01e+08. In the year 2009, what is the difference between the Expenses (in $) of Miscellaneous expenses and Expenses (in $) of Labor Taxes?
Give a very brief answer. 3.24e+09. In the year 2009, what is the difference between the Expenses (in $) of Miscellaneous expenses and Expenses (in $) of Grants and Revenue?
Offer a very short reply. 4.64e+08. In the year 2009, what is the difference between the Expenses (in $) in Miscellaneous expenses and Expenses (in $) in Services?
Give a very brief answer. 1.50e+09. In the year 2009, what is the difference between the Expenses (in $) of Labor Taxes and Expenses (in $) of Grants and Revenue?
Make the answer very short. -2.78e+09. In the year 2009, what is the difference between the Expenses (in $) of Labor Taxes and Expenses (in $) of Services?
Ensure brevity in your answer.  -1.74e+09. In the year 2009, what is the difference between the Expenses (in $) in Grants and Revenue and Expenses (in $) in Services?
Offer a terse response. 1.03e+09. In the year 2010, what is the difference between the Expenses (in $) of Miscellaneous expenses and Expenses (in $) of Labor Taxes?
Provide a succinct answer. 2.84e+09. In the year 2010, what is the difference between the Expenses (in $) in Miscellaneous expenses and Expenses (in $) in Grants and Revenue?
Give a very brief answer. 1.83e+08. In the year 2010, what is the difference between the Expenses (in $) in Miscellaneous expenses and Expenses (in $) in Services?
Ensure brevity in your answer.  1.08e+09. In the year 2010, what is the difference between the Expenses (in $) in Labor Taxes and Expenses (in $) in Grants and Revenue?
Offer a very short reply. -2.66e+09. In the year 2010, what is the difference between the Expenses (in $) of Labor Taxes and Expenses (in $) of Services?
Offer a very short reply. -1.76e+09. In the year 2010, what is the difference between the Expenses (in $) of Grants and Revenue and Expenses (in $) of Services?
Your answer should be compact. 8.99e+08. In the year 2011, what is the difference between the Expenses (in $) in Miscellaneous expenses and Expenses (in $) in Labor Taxes?
Your answer should be compact. 2.36e+09. In the year 2011, what is the difference between the Expenses (in $) in Miscellaneous expenses and Expenses (in $) in Grants and Revenue?
Offer a terse response. -7.71e+08. In the year 2011, what is the difference between the Expenses (in $) of Miscellaneous expenses and Expenses (in $) of Services?
Provide a succinct answer. 2.79e+08. In the year 2011, what is the difference between the Expenses (in $) in Labor Taxes and Expenses (in $) in Grants and Revenue?
Offer a terse response. -3.13e+09. In the year 2011, what is the difference between the Expenses (in $) of Labor Taxes and Expenses (in $) of Services?
Your answer should be very brief. -2.08e+09. In the year 2011, what is the difference between the Expenses (in $) in Grants and Revenue and Expenses (in $) in Services?
Make the answer very short. 1.05e+09. In the year 2012, what is the difference between the Expenses (in $) of Miscellaneous expenses and Expenses (in $) of Labor Taxes?
Make the answer very short. 2.10e+09. In the year 2012, what is the difference between the Expenses (in $) of Miscellaneous expenses and Expenses (in $) of Grants and Revenue?
Provide a succinct answer. -8.41e+08. In the year 2012, what is the difference between the Expenses (in $) of Miscellaneous expenses and Expenses (in $) of Services?
Your answer should be compact. 7.85e+08. In the year 2012, what is the difference between the Expenses (in $) of Labor Taxes and Expenses (in $) of Grants and Revenue?
Provide a succinct answer. -2.94e+09. In the year 2012, what is the difference between the Expenses (in $) in Labor Taxes and Expenses (in $) in Services?
Your answer should be compact. -1.31e+09. In the year 2012, what is the difference between the Expenses (in $) in Grants and Revenue and Expenses (in $) in Services?
Give a very brief answer. 1.63e+09. What is the ratio of the Expenses (in $) of Labor Taxes in 2005 to that in 2006?
Offer a terse response. 1.96. What is the ratio of the Expenses (in $) of Grants and Revenue in 2005 to that in 2006?
Make the answer very short. 0.78. What is the ratio of the Expenses (in $) in Services in 2005 to that in 2006?
Make the answer very short. 0.88. What is the ratio of the Expenses (in $) in Miscellaneous expenses in 2005 to that in 2007?
Keep it short and to the point. 1.16. What is the ratio of the Expenses (in $) of Labor Taxes in 2005 to that in 2007?
Make the answer very short. 10.71. What is the ratio of the Expenses (in $) in Grants and Revenue in 2005 to that in 2007?
Ensure brevity in your answer.  0.97. What is the ratio of the Expenses (in $) of Services in 2005 to that in 2007?
Your response must be concise. 1.02. What is the ratio of the Expenses (in $) in Miscellaneous expenses in 2005 to that in 2008?
Keep it short and to the point. 1.18. What is the ratio of the Expenses (in $) of Labor Taxes in 2005 to that in 2008?
Your answer should be very brief. 19.89. What is the ratio of the Expenses (in $) of Grants and Revenue in 2005 to that in 2008?
Your answer should be compact. 0.75. What is the ratio of the Expenses (in $) in Services in 2005 to that in 2008?
Provide a succinct answer. 0.81. What is the ratio of the Expenses (in $) of Miscellaneous expenses in 2005 to that in 2009?
Provide a succinct answer. 0.67. What is the ratio of the Expenses (in $) of Labor Taxes in 2005 to that in 2009?
Your answer should be very brief. 38.19. What is the ratio of the Expenses (in $) in Grants and Revenue in 2005 to that in 2009?
Keep it short and to the point. 0.73. What is the ratio of the Expenses (in $) in Services in 2005 to that in 2009?
Your response must be concise. 1.02. What is the ratio of the Expenses (in $) in Miscellaneous expenses in 2005 to that in 2010?
Provide a succinct answer. 0.76. What is the ratio of the Expenses (in $) in Labor Taxes in 2005 to that in 2010?
Your answer should be compact. 76.64. What is the ratio of the Expenses (in $) of Grants and Revenue in 2005 to that in 2010?
Provide a succinct answer. 0.76. What is the ratio of the Expenses (in $) of Services in 2005 to that in 2010?
Provide a short and direct response. 1.01. What is the ratio of the Expenses (in $) of Miscellaneous expenses in 2005 to that in 2011?
Offer a very short reply. 0.9. What is the ratio of the Expenses (in $) of Labor Taxes in 2005 to that in 2011?
Offer a terse response. 0.67. What is the ratio of the Expenses (in $) in Grants and Revenue in 2005 to that in 2011?
Your answer should be very brief. 0.64. What is the ratio of the Expenses (in $) in Services in 2005 to that in 2011?
Keep it short and to the point. 0.84. What is the ratio of the Expenses (in $) in Miscellaneous expenses in 2005 to that in 2012?
Your answer should be very brief. 0.92. What is the ratio of the Expenses (in $) in Labor Taxes in 2005 to that in 2012?
Provide a short and direct response. 0.12. What is the ratio of the Expenses (in $) in Grants and Revenue in 2005 to that in 2012?
Give a very brief answer. 0.64. What is the ratio of the Expenses (in $) in Services in 2005 to that in 2012?
Make the answer very short. 1.14. What is the ratio of the Expenses (in $) of Miscellaneous expenses in 2006 to that in 2007?
Ensure brevity in your answer.  1.16. What is the ratio of the Expenses (in $) in Labor Taxes in 2006 to that in 2007?
Your answer should be very brief. 5.46. What is the ratio of the Expenses (in $) in Grants and Revenue in 2006 to that in 2007?
Offer a terse response. 1.24. What is the ratio of the Expenses (in $) in Services in 2006 to that in 2007?
Your answer should be compact. 1.16. What is the ratio of the Expenses (in $) in Miscellaneous expenses in 2006 to that in 2008?
Provide a short and direct response. 1.18. What is the ratio of the Expenses (in $) of Labor Taxes in 2006 to that in 2008?
Your response must be concise. 10.14. What is the ratio of the Expenses (in $) of Grants and Revenue in 2006 to that in 2008?
Your response must be concise. 0.96. What is the ratio of the Expenses (in $) of Services in 2006 to that in 2008?
Ensure brevity in your answer.  0.92. What is the ratio of the Expenses (in $) in Miscellaneous expenses in 2006 to that in 2009?
Keep it short and to the point. 0.67. What is the ratio of the Expenses (in $) in Labor Taxes in 2006 to that in 2009?
Offer a terse response. 19.46. What is the ratio of the Expenses (in $) in Grants and Revenue in 2006 to that in 2009?
Your answer should be very brief. 0.93. What is the ratio of the Expenses (in $) in Services in 2006 to that in 2009?
Give a very brief answer. 1.15. What is the ratio of the Expenses (in $) in Miscellaneous expenses in 2006 to that in 2010?
Ensure brevity in your answer.  0.76. What is the ratio of the Expenses (in $) of Labor Taxes in 2006 to that in 2010?
Keep it short and to the point. 39.06. What is the ratio of the Expenses (in $) in Grants and Revenue in 2006 to that in 2010?
Keep it short and to the point. 0.97. What is the ratio of the Expenses (in $) in Services in 2006 to that in 2010?
Offer a very short reply. 1.14. What is the ratio of the Expenses (in $) in Miscellaneous expenses in 2006 to that in 2011?
Ensure brevity in your answer.  0.9. What is the ratio of the Expenses (in $) of Labor Taxes in 2006 to that in 2011?
Offer a terse response. 0.34. What is the ratio of the Expenses (in $) in Grants and Revenue in 2006 to that in 2011?
Ensure brevity in your answer.  0.82. What is the ratio of the Expenses (in $) of Services in 2006 to that in 2011?
Offer a terse response. 0.95. What is the ratio of the Expenses (in $) in Miscellaneous expenses in 2006 to that in 2012?
Provide a succinct answer. 0.93. What is the ratio of the Expenses (in $) of Labor Taxes in 2006 to that in 2012?
Your answer should be very brief. 0.06. What is the ratio of the Expenses (in $) of Grants and Revenue in 2006 to that in 2012?
Your answer should be compact. 0.81. What is the ratio of the Expenses (in $) in Services in 2006 to that in 2012?
Make the answer very short. 1.29. What is the ratio of the Expenses (in $) in Miscellaneous expenses in 2007 to that in 2008?
Offer a terse response. 1.02. What is the ratio of the Expenses (in $) in Labor Taxes in 2007 to that in 2008?
Your answer should be compact. 1.86. What is the ratio of the Expenses (in $) of Grants and Revenue in 2007 to that in 2008?
Offer a very short reply. 0.78. What is the ratio of the Expenses (in $) in Services in 2007 to that in 2008?
Provide a short and direct response. 0.79. What is the ratio of the Expenses (in $) of Miscellaneous expenses in 2007 to that in 2009?
Your answer should be compact. 0.58. What is the ratio of the Expenses (in $) of Labor Taxes in 2007 to that in 2009?
Your response must be concise. 3.56. What is the ratio of the Expenses (in $) in Grants and Revenue in 2007 to that in 2009?
Provide a succinct answer. 0.75. What is the ratio of the Expenses (in $) of Services in 2007 to that in 2009?
Your answer should be compact. 0.99. What is the ratio of the Expenses (in $) in Miscellaneous expenses in 2007 to that in 2010?
Ensure brevity in your answer.  0.66. What is the ratio of the Expenses (in $) of Labor Taxes in 2007 to that in 2010?
Ensure brevity in your answer.  7.15. What is the ratio of the Expenses (in $) of Grants and Revenue in 2007 to that in 2010?
Offer a very short reply. 0.79. What is the ratio of the Expenses (in $) of Services in 2007 to that in 2010?
Your answer should be very brief. 0.98. What is the ratio of the Expenses (in $) of Miscellaneous expenses in 2007 to that in 2011?
Your response must be concise. 0.78. What is the ratio of the Expenses (in $) of Labor Taxes in 2007 to that in 2011?
Keep it short and to the point. 0.06. What is the ratio of the Expenses (in $) in Grants and Revenue in 2007 to that in 2011?
Ensure brevity in your answer.  0.66. What is the ratio of the Expenses (in $) of Services in 2007 to that in 2011?
Keep it short and to the point. 0.82. What is the ratio of the Expenses (in $) in Miscellaneous expenses in 2007 to that in 2012?
Your answer should be compact. 0.8. What is the ratio of the Expenses (in $) of Labor Taxes in 2007 to that in 2012?
Ensure brevity in your answer.  0.01. What is the ratio of the Expenses (in $) in Grants and Revenue in 2007 to that in 2012?
Give a very brief answer. 0.66. What is the ratio of the Expenses (in $) of Services in 2007 to that in 2012?
Offer a very short reply. 1.11. What is the ratio of the Expenses (in $) in Miscellaneous expenses in 2008 to that in 2009?
Your answer should be compact. 0.57. What is the ratio of the Expenses (in $) in Labor Taxes in 2008 to that in 2009?
Offer a very short reply. 1.92. What is the ratio of the Expenses (in $) in Grants and Revenue in 2008 to that in 2009?
Offer a terse response. 0.97. What is the ratio of the Expenses (in $) in Services in 2008 to that in 2009?
Keep it short and to the point. 1.25. What is the ratio of the Expenses (in $) in Miscellaneous expenses in 2008 to that in 2010?
Provide a short and direct response. 0.65. What is the ratio of the Expenses (in $) in Labor Taxes in 2008 to that in 2010?
Your answer should be very brief. 3.85. What is the ratio of the Expenses (in $) of Grants and Revenue in 2008 to that in 2010?
Provide a short and direct response. 1.01. What is the ratio of the Expenses (in $) in Services in 2008 to that in 2010?
Ensure brevity in your answer.  1.24. What is the ratio of the Expenses (in $) of Miscellaneous expenses in 2008 to that in 2011?
Keep it short and to the point. 0.76. What is the ratio of the Expenses (in $) of Labor Taxes in 2008 to that in 2011?
Offer a very short reply. 0.03. What is the ratio of the Expenses (in $) in Grants and Revenue in 2008 to that in 2011?
Your answer should be compact. 0.85. What is the ratio of the Expenses (in $) in Services in 2008 to that in 2011?
Your answer should be compact. 1.03. What is the ratio of the Expenses (in $) in Miscellaneous expenses in 2008 to that in 2012?
Offer a terse response. 0.78. What is the ratio of the Expenses (in $) in Labor Taxes in 2008 to that in 2012?
Your response must be concise. 0.01. What is the ratio of the Expenses (in $) in Grants and Revenue in 2008 to that in 2012?
Ensure brevity in your answer.  0.84. What is the ratio of the Expenses (in $) in Services in 2008 to that in 2012?
Offer a very short reply. 1.4. What is the ratio of the Expenses (in $) in Miscellaneous expenses in 2009 to that in 2010?
Offer a terse response. 1.14. What is the ratio of the Expenses (in $) of Labor Taxes in 2009 to that in 2010?
Provide a short and direct response. 2.01. What is the ratio of the Expenses (in $) of Grants and Revenue in 2009 to that in 2010?
Provide a succinct answer. 1.05. What is the ratio of the Expenses (in $) in Services in 2009 to that in 2010?
Offer a terse response. 0.99. What is the ratio of the Expenses (in $) in Miscellaneous expenses in 2009 to that in 2011?
Your answer should be very brief. 1.35. What is the ratio of the Expenses (in $) in Labor Taxes in 2009 to that in 2011?
Your answer should be very brief. 0.02. What is the ratio of the Expenses (in $) of Grants and Revenue in 2009 to that in 2011?
Make the answer very short. 0.88. What is the ratio of the Expenses (in $) in Services in 2009 to that in 2011?
Provide a succinct answer. 0.82. What is the ratio of the Expenses (in $) of Miscellaneous expenses in 2009 to that in 2012?
Your response must be concise. 1.39. What is the ratio of the Expenses (in $) in Labor Taxes in 2009 to that in 2012?
Make the answer very short. 0. What is the ratio of the Expenses (in $) in Grants and Revenue in 2009 to that in 2012?
Give a very brief answer. 0.87. What is the ratio of the Expenses (in $) of Services in 2009 to that in 2012?
Make the answer very short. 1.12. What is the ratio of the Expenses (in $) in Miscellaneous expenses in 2010 to that in 2011?
Give a very brief answer. 1.18. What is the ratio of the Expenses (in $) of Labor Taxes in 2010 to that in 2011?
Your answer should be compact. 0.01. What is the ratio of the Expenses (in $) in Grants and Revenue in 2010 to that in 2011?
Keep it short and to the point. 0.84. What is the ratio of the Expenses (in $) in Services in 2010 to that in 2011?
Your answer should be compact. 0.83. What is the ratio of the Expenses (in $) in Miscellaneous expenses in 2010 to that in 2012?
Offer a terse response. 1.21. What is the ratio of the Expenses (in $) in Labor Taxes in 2010 to that in 2012?
Provide a short and direct response. 0. What is the ratio of the Expenses (in $) in Grants and Revenue in 2010 to that in 2012?
Offer a terse response. 0.84. What is the ratio of the Expenses (in $) of Services in 2010 to that in 2012?
Your response must be concise. 1.13. What is the ratio of the Expenses (in $) of Miscellaneous expenses in 2011 to that in 2012?
Keep it short and to the point. 1.03. What is the ratio of the Expenses (in $) of Labor Taxes in 2011 to that in 2012?
Offer a terse response. 0.17. What is the ratio of the Expenses (in $) of Services in 2011 to that in 2012?
Ensure brevity in your answer.  1.36. What is the difference between the highest and the second highest Expenses (in $) of Miscellaneous expenses?
Offer a terse response. 4.00e+08. What is the difference between the highest and the second highest Expenses (in $) in Labor Taxes?
Your response must be concise. 1.99e+08. What is the difference between the highest and the second highest Expenses (in $) in Grants and Revenue?
Keep it short and to the point. 8.98e+06. What is the difference between the highest and the second highest Expenses (in $) in Services?
Offer a terse response. 6.11e+07. What is the difference between the highest and the lowest Expenses (in $) in Miscellaneous expenses?
Your response must be concise. 1.41e+09. What is the difference between the highest and the lowest Expenses (in $) of Labor Taxes?
Your answer should be compact. 2.40e+08. What is the difference between the highest and the lowest Expenses (in $) of Grants and Revenue?
Your answer should be very brief. 1.16e+09. What is the difference between the highest and the lowest Expenses (in $) in Services?
Ensure brevity in your answer.  6.28e+08. 